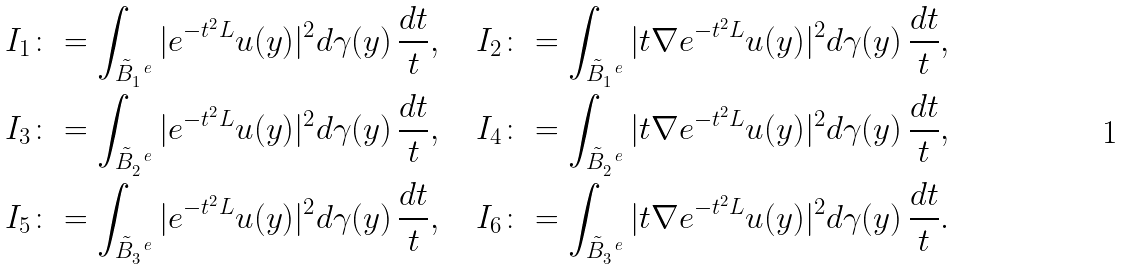<formula> <loc_0><loc_0><loc_500><loc_500>I _ { 1 } & \colon = \int _ { \tilde { B } ^ { \ e } _ { 1 } } | e ^ { - t ^ { 2 } L } u ( y ) | ^ { 2 } d \gamma ( y ) \, \frac { d t } { t } , \quad I _ { 2 } \colon = \int _ { \tilde { B } ^ { \ e } _ { 1 } } | t \nabla e ^ { - t ^ { 2 } L } u ( y ) | ^ { 2 } d \gamma ( y ) \, \frac { d t } { t } , \\ I _ { 3 } & \colon = \int _ { \tilde { B } ^ { \ e } _ { 2 } } | e ^ { - t ^ { 2 } L } u ( y ) | ^ { 2 } d \gamma ( y ) \, \frac { d t } { t } , \quad I _ { 4 } \colon = \int _ { \tilde { B } ^ { \ e } _ { 2 } } | t \nabla e ^ { - t ^ { 2 } L } u ( y ) | ^ { 2 } d \gamma ( y ) \, \frac { d t } { t } , \\ I _ { 5 } & \colon = \int _ { \tilde { B } ^ { \ e } _ { 3 } } | e ^ { - t ^ { 2 } L } u ( y ) | ^ { 2 } d \gamma ( y ) \, \frac { d t } { t } , \quad I _ { 6 } \colon = \int _ { \tilde { B } ^ { \ e } _ { 3 } } | t \nabla e ^ { - t ^ { 2 } L } u ( y ) | ^ { 2 } d \gamma ( y ) \, \frac { d t } { t } .</formula> 